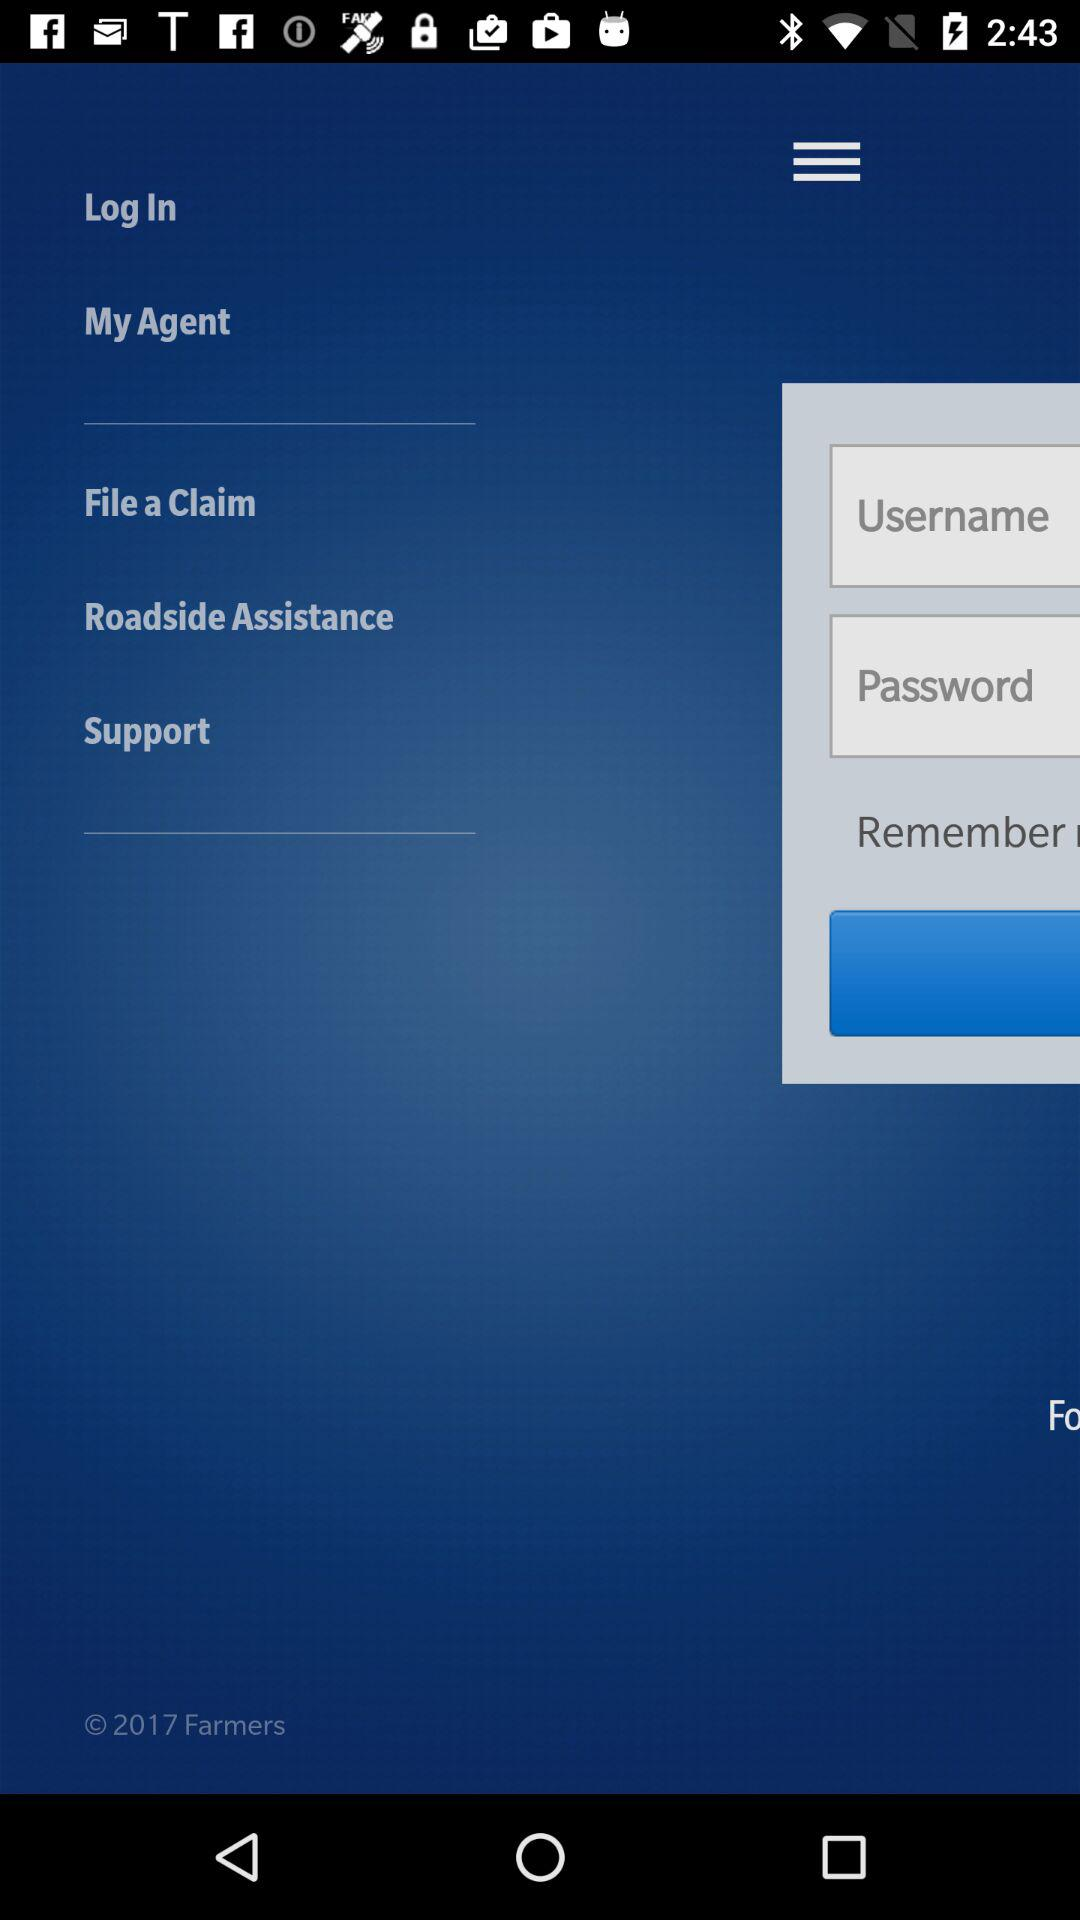How many text input fields are there on the screen?
Answer the question using a single word or phrase. 2 